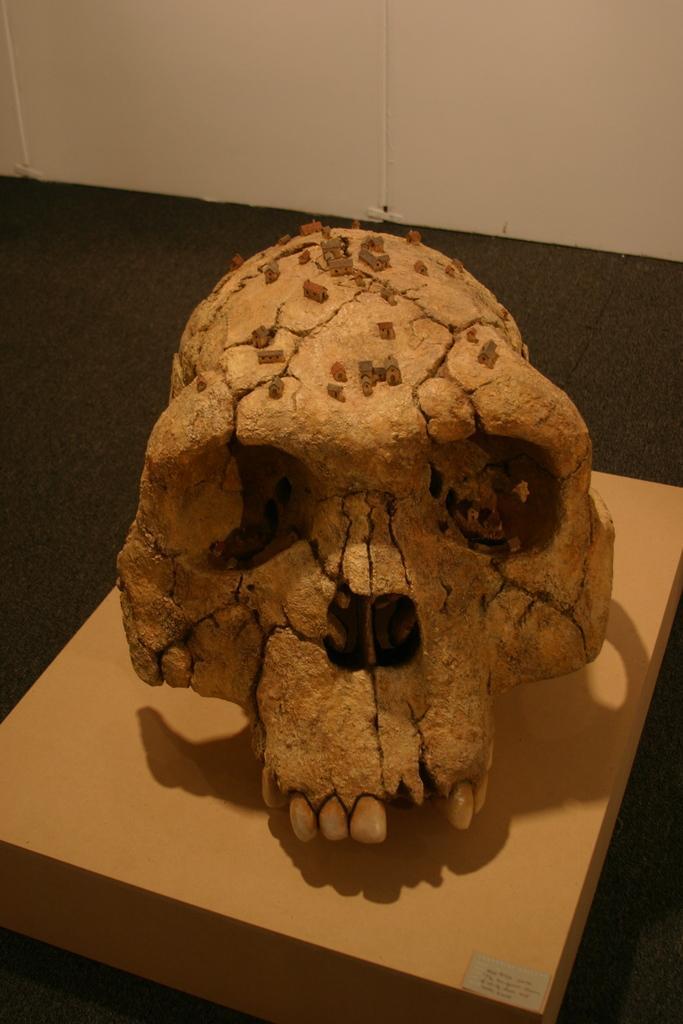How would you summarize this image in a sentence or two? In this image there is a skull on the wooden material which is kept on the floor. Top of image there is wall. 